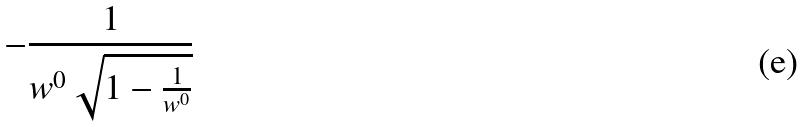<formula> <loc_0><loc_0><loc_500><loc_500>- \frac { 1 } { w ^ { 0 } \sqrt { 1 - \frac { 1 } { w ^ { 0 } } } }</formula> 